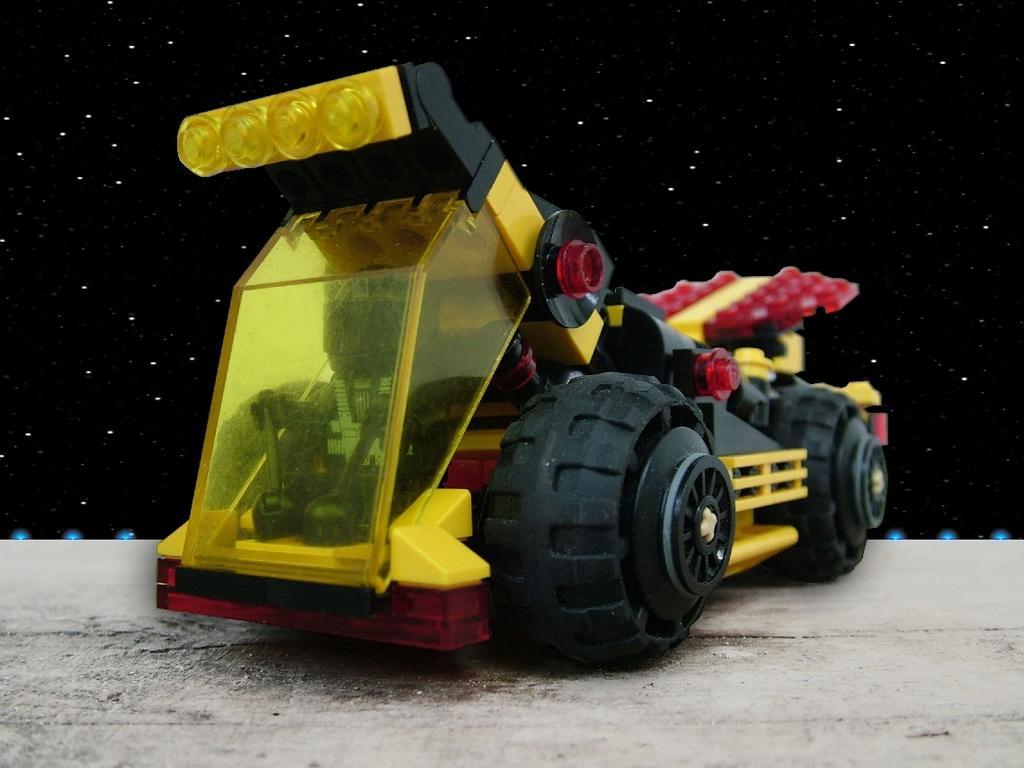Can you describe this image briefly? In the image in the center we can see one toy vehicles,which is in yellow,black and red color. 